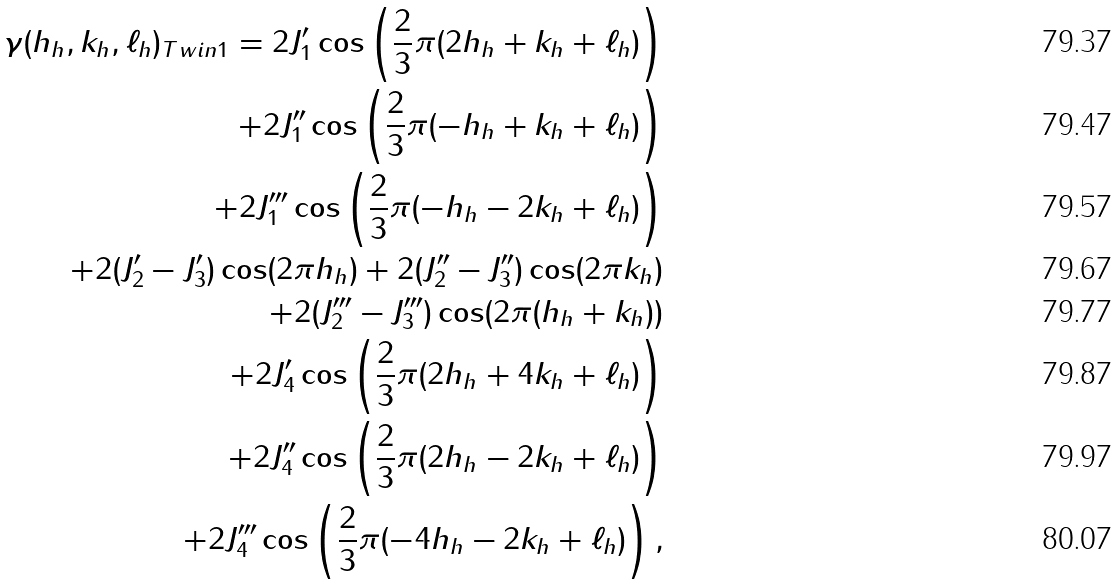Convert formula to latex. <formula><loc_0><loc_0><loc_500><loc_500>\gamma ( h _ { h } , k _ { h } , \ell _ { h } ) _ { T w i n 1 } = 2 J ^ { \prime } _ { 1 } \cos \left ( \frac { 2 } { 3 } \pi ( 2 h _ { h } + k _ { h } + \ell _ { h } ) \right ) \\ + 2 J ^ { \prime \prime } _ { 1 } \cos \left ( \frac { 2 } { 3 } \pi ( - h _ { h } + k _ { h } + \ell _ { h } ) \right ) \\ + 2 J ^ { \prime \prime \prime } _ { 1 } \cos \left ( \frac { 2 } { 3 } \pi ( - h _ { h } - 2 k _ { h } + \ell _ { h } ) \right ) \\ + 2 ( J ^ { \prime } _ { 2 } - J ^ { \prime } _ { 3 } ) \cos ( 2 \pi h _ { h } ) + 2 ( J ^ { \prime \prime } _ { 2 } - J ^ { \prime \prime } _ { 3 } ) \cos ( 2 \pi k _ { h } ) \\ + 2 ( J ^ { \prime \prime \prime } _ { 2 } - J ^ { \prime \prime \prime } _ { 3 } ) \cos ( 2 \pi ( h _ { h } + k _ { h } ) ) \\ + 2 J ^ { \prime } _ { 4 } \cos \left ( \frac { 2 } { 3 } \pi ( 2 h _ { h } + 4 k _ { h } + \ell _ { h } ) \right ) \\ + 2 J ^ { \prime \prime } _ { 4 } \cos \left ( \frac { 2 } { 3 } \pi ( 2 h _ { h } - 2 k _ { h } + \ell _ { h } ) \right ) \\ + 2 J ^ { \prime \prime \prime } _ { 4 } \cos \left ( \frac { 2 } { 3 } \pi ( - 4 h _ { h } - 2 k _ { h } + \ell _ { h } ) \right ) ,</formula> 